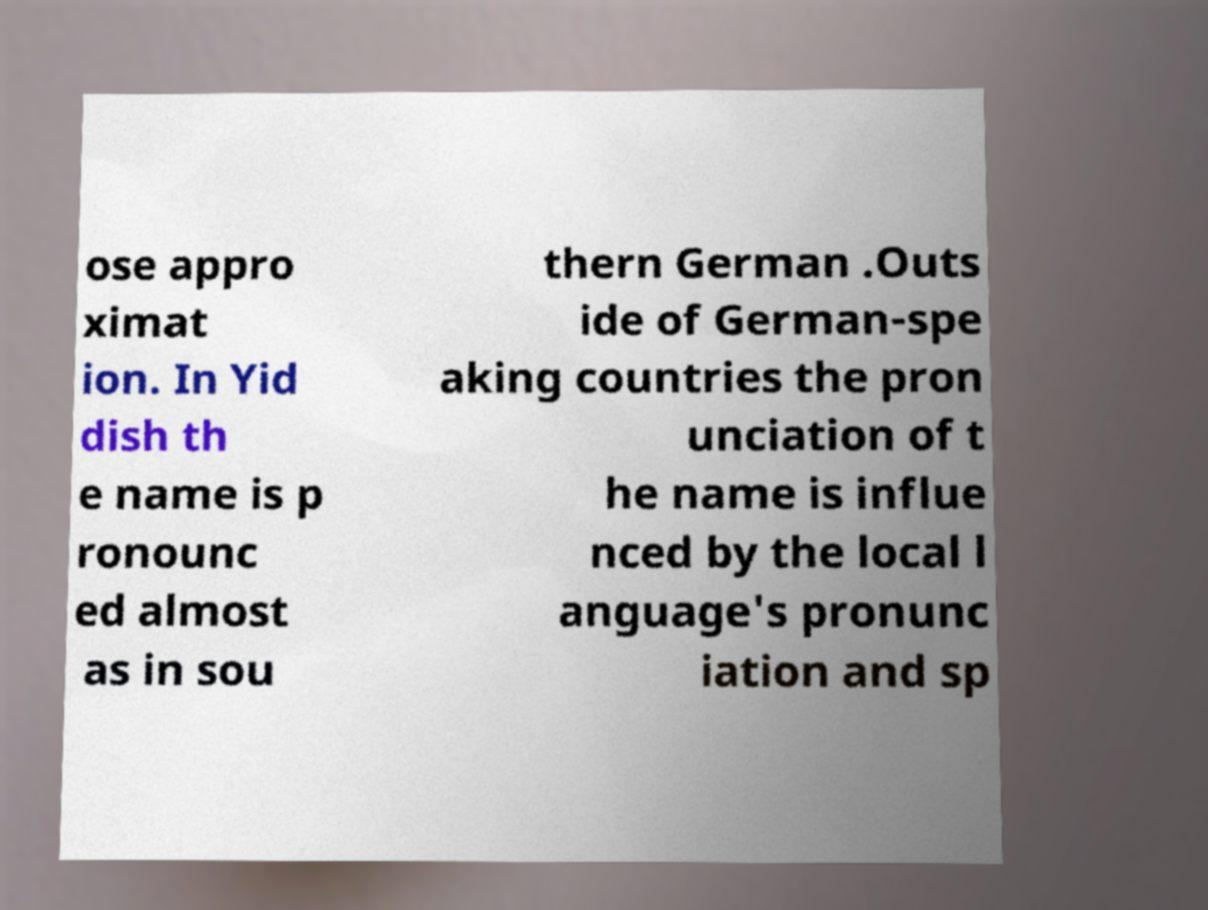Can you read and provide the text displayed in the image?This photo seems to have some interesting text. Can you extract and type it out for me? ose appro ximat ion. In Yid dish th e name is p ronounc ed almost as in sou thern German .Outs ide of German-spe aking countries the pron unciation of t he name is influe nced by the local l anguage's pronunc iation and sp 